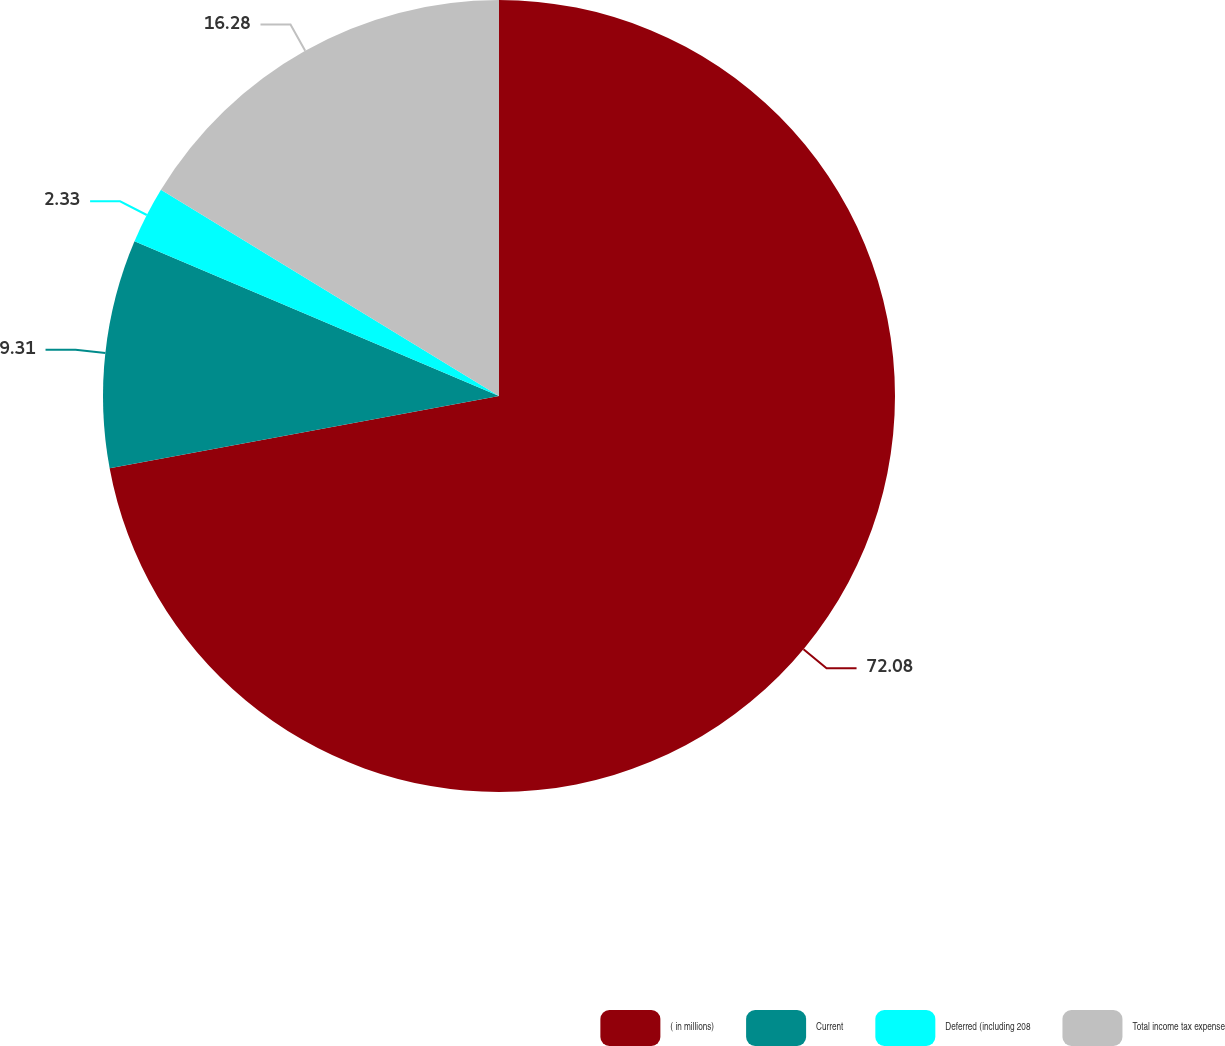Convert chart. <chart><loc_0><loc_0><loc_500><loc_500><pie_chart><fcel>( in millions)<fcel>Current<fcel>Deferred (including 208<fcel>Total income tax expense<nl><fcel>72.08%<fcel>9.31%<fcel>2.33%<fcel>16.28%<nl></chart> 